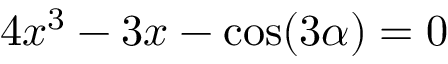<formula> <loc_0><loc_0><loc_500><loc_500>4 x ^ { 3 } - 3 x - \cos ( 3 \alpha ) = 0</formula> 